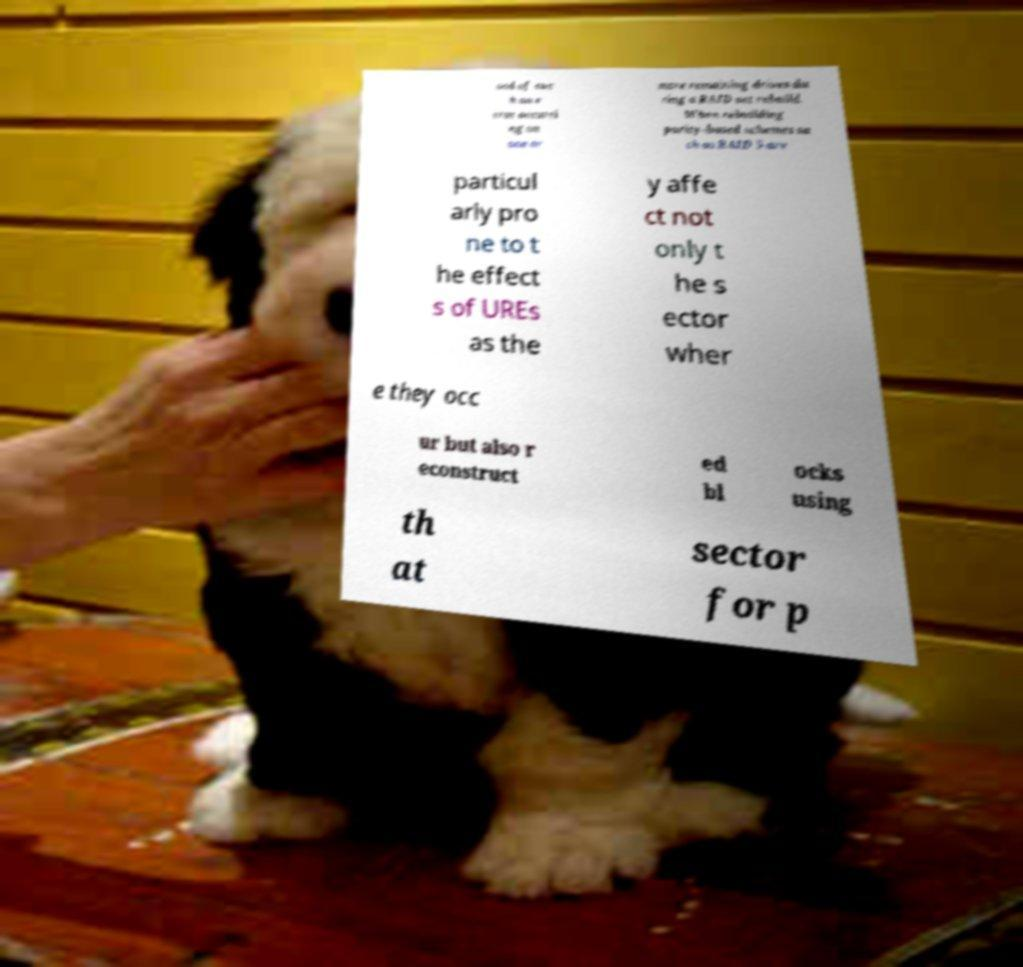For documentation purposes, I need the text within this image transcribed. Could you provide that? ood of suc h an e rror occurri ng on one or more remaining drives du ring a RAID set rebuild. When rebuilding parity-based schemes su ch as RAID 5 are particul arly pro ne to t he effect s of UREs as the y affe ct not only t he s ector wher e they occ ur but also r econstruct ed bl ocks using th at sector for p 